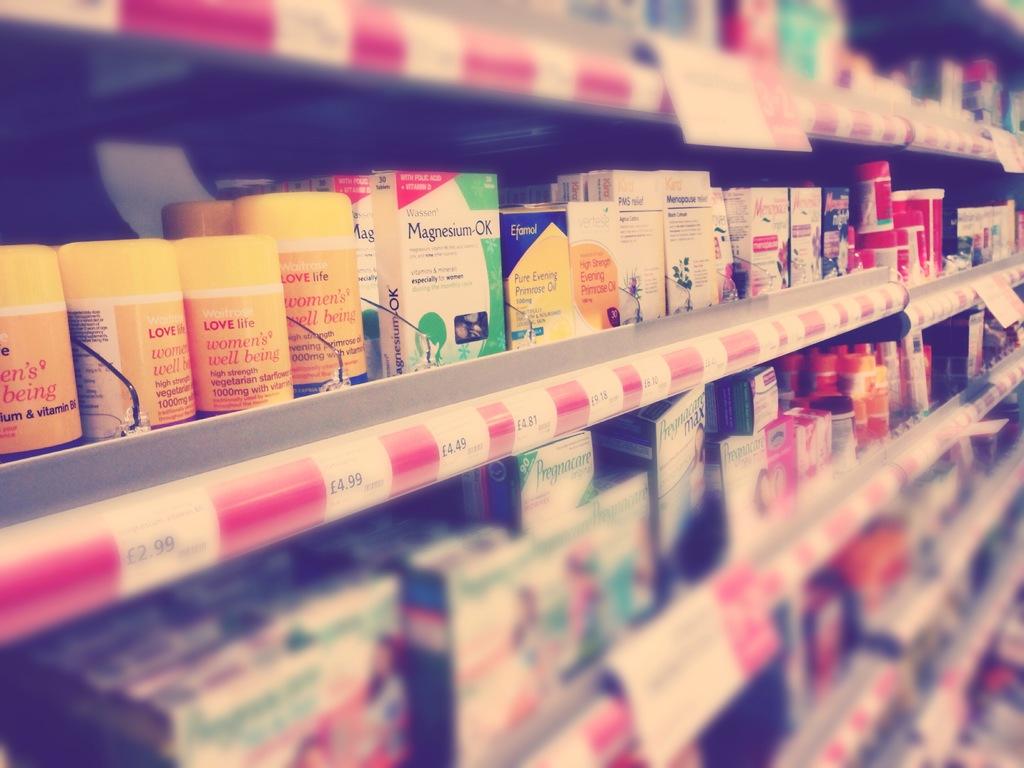What kind of medicine do they have?
Your answer should be very brief. Unanswerable. What is shown in the yellow bottle farthest left?
Your response must be concise. Love life. 